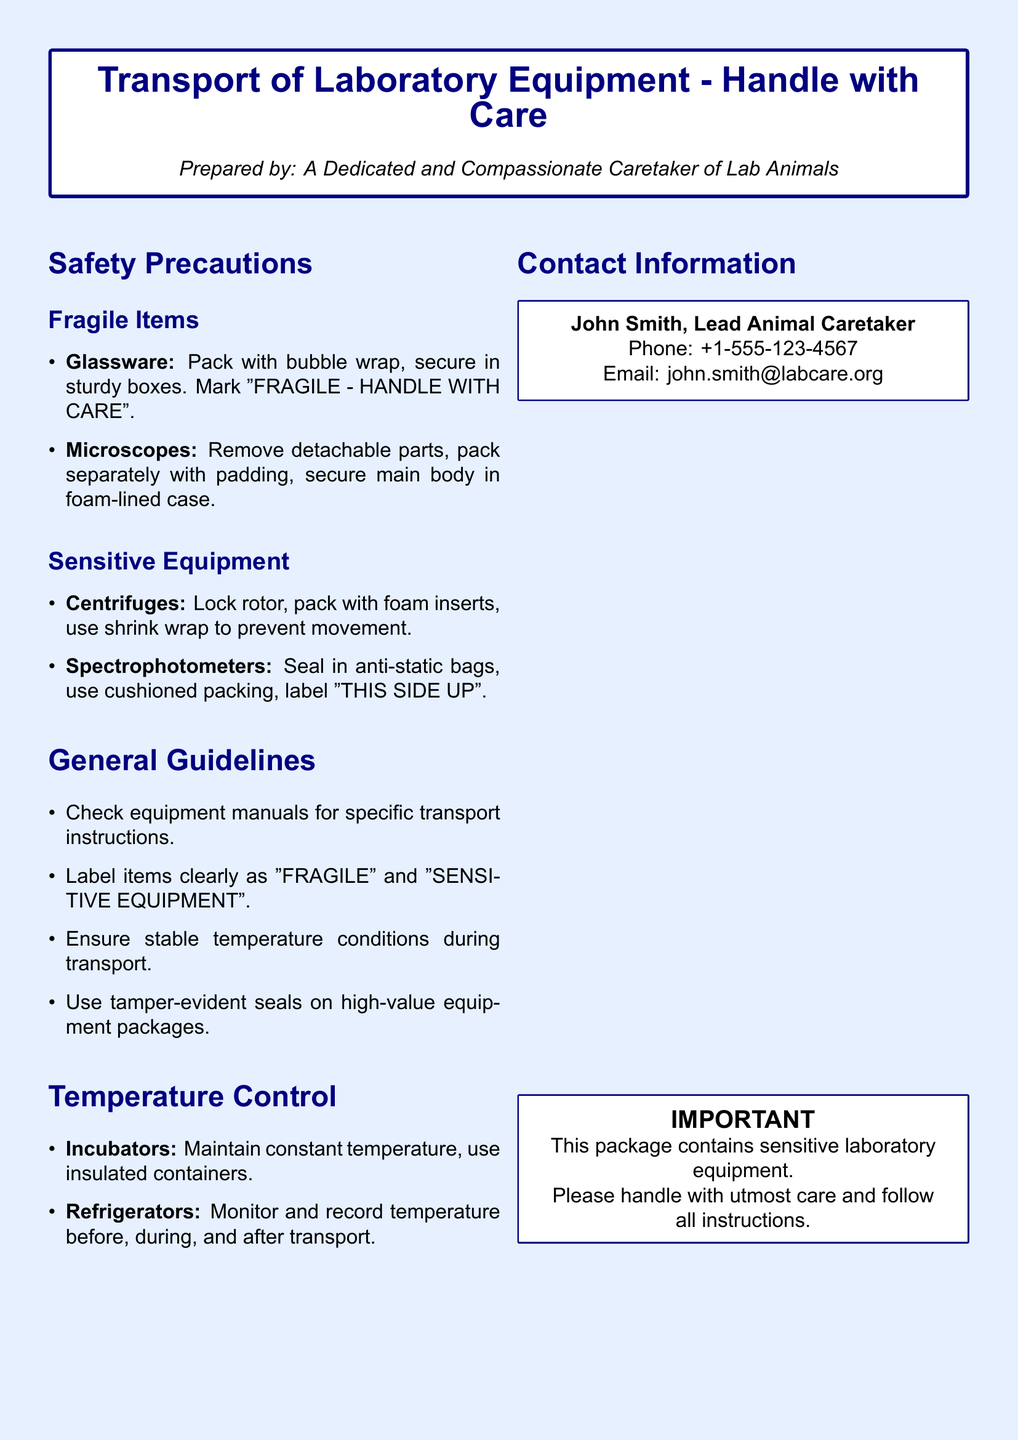What is the name of the lead animal caretaker? The document specifies the contact information section, which includes the name of the lead animal caretaker.
Answer: John Smith What should be packed with bubble wrap? The section on fragile items mentions specific equipment that needs special packing, such as glassware.
Answer: Glassware What items should be clearly labeled as "SENSITIVE EQUIPMENT"? The general guidelines state to label items clearly, which includes sensitive equipment that requires special handling.
Answer: Sensitive equipment What temperature control method is recommended for incubators? The section on temperature control provides guidelines for incubators.
Answer: Insulated containers How should microscopes be packed? The precautions for sensitive items outline how to properly pack microscopes to ensure their safety during transport.
Answer: Pack separately with padding What specific equipment requires monitoring and recording temperature? The document mentions specific types of equipment that are sensitive to temperature fluctuations, necessitating monitoring.
Answer: Refrigerators Which packaging method is recommended for centrifuges? The precautions for sensitive equipment provide guidance on how to package centrifuges properly to protect them during transport.
Answer: Foam inserts What should be used on high-value equipment packages? The general guidelines provide a strategy for securing high-value equipment, emphasizing the need for extra protection.
Answer: Tamper-evident seals 